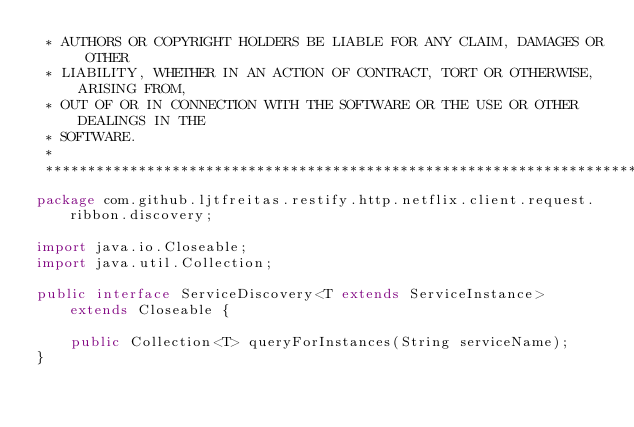<code> <loc_0><loc_0><loc_500><loc_500><_Java_> * AUTHORS OR COPYRIGHT HOLDERS BE LIABLE FOR ANY CLAIM, DAMAGES OR OTHER
 * LIABILITY, WHETHER IN AN ACTION OF CONTRACT, TORT OR OTHERWISE, ARISING FROM,
 * OUT OF OR IN CONNECTION WITH THE SOFTWARE OR THE USE OR OTHER DEALINGS IN THE
 * SOFTWARE.
 *
 *******************************************************************************/
package com.github.ljtfreitas.restify.http.netflix.client.request.ribbon.discovery;

import java.io.Closeable;
import java.util.Collection;

public interface ServiceDiscovery<T extends ServiceInstance> extends Closeable {

	public Collection<T> queryForInstances(String serviceName);
}
</code> 